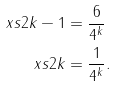<formula> <loc_0><loc_0><loc_500><loc_500>\ x s { 2 k - 1 } & = \frac { 6 } { 4 ^ { k } } \\ \ x s { 2 k } & = \frac { 1 } { 4 ^ { k } } .</formula> 